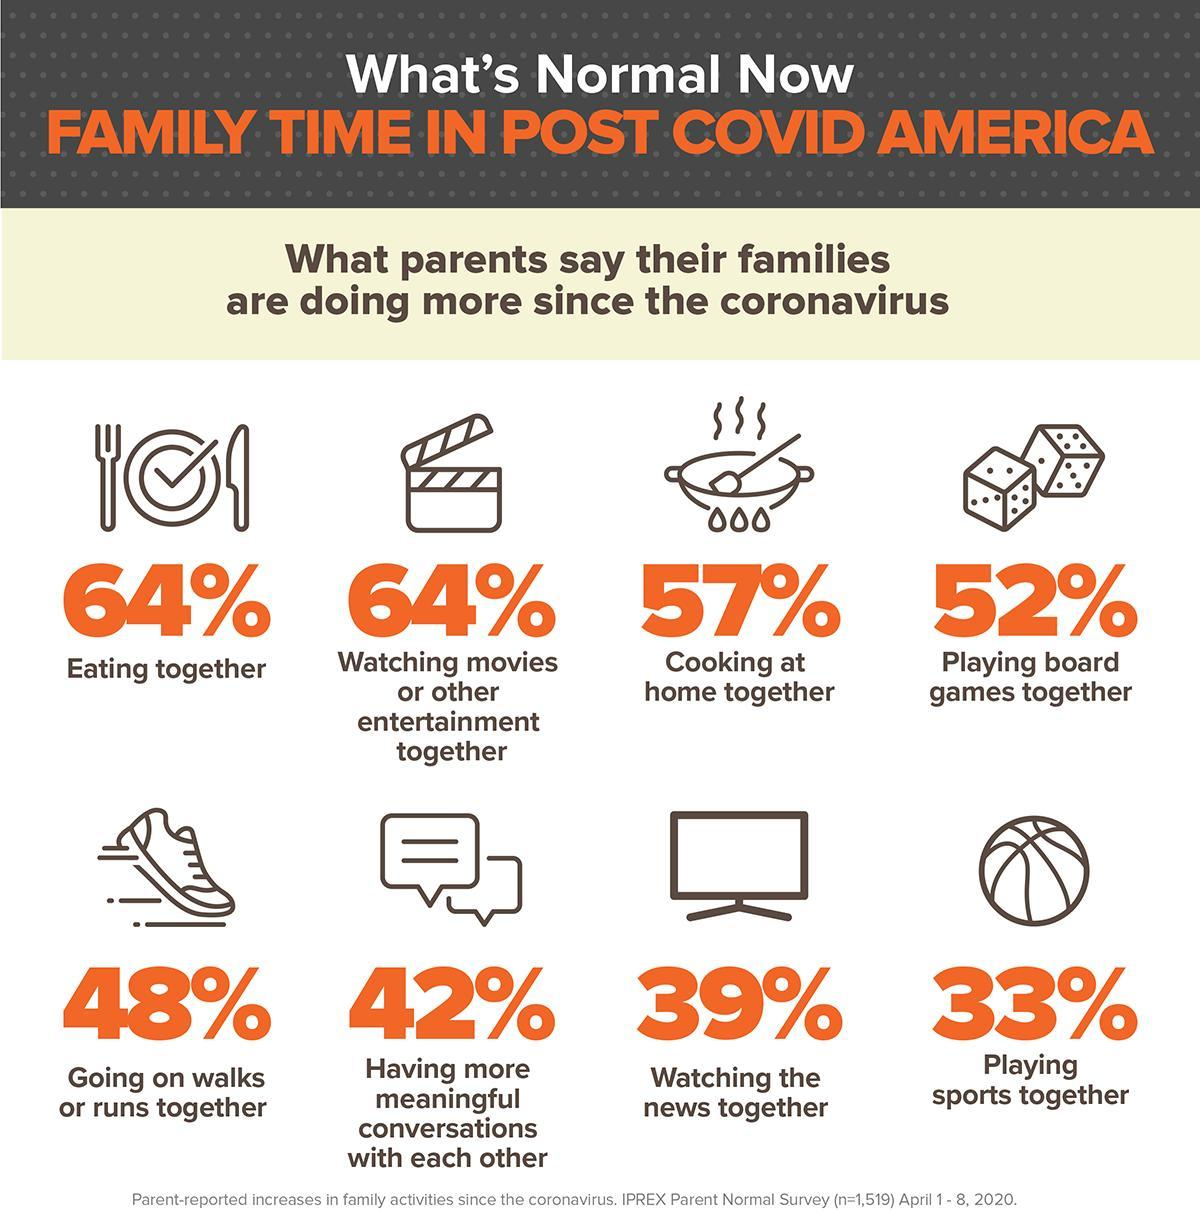What percentage of Americans are interested to watch the latest updates?
Answer the question with a short phrase. 39% What percentage of Americans are having food with family? 64% What percentage of Americans are interested in jogging since the corona virus? 48% What percentage of Americans are preparing food by their own since the corona virus? 57% What percentage of Americans are making fruitful conversations with others? 42% What percentage of Americans are watching films at home since the corona virus? 64% 